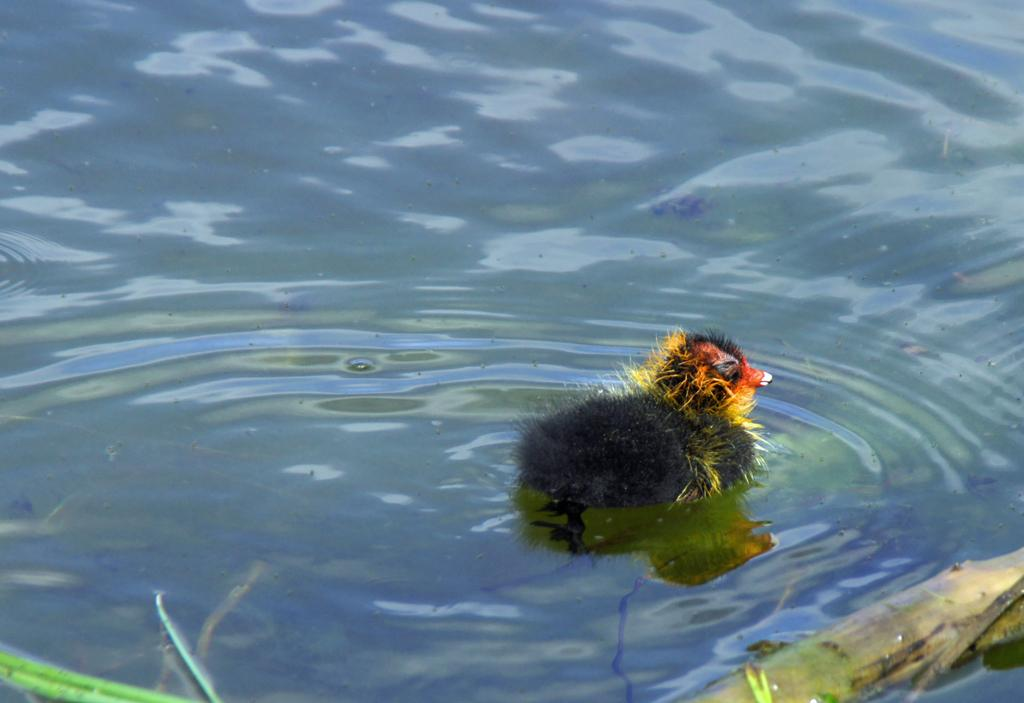What is the bird doing in the image? The bird is in the water in the image. What can be seen in the bottom right corner of the image? There is an object on the bottom right corner of the image. What can be seen in the bottom left corner of the image? There is an object on the bottom left corner of the image. What type of meat is being folded by the bird in the image? There is no meat present in the image, and the bird is not folding anything. 